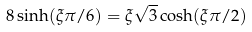<formula> <loc_0><loc_0><loc_500><loc_500>8 \sinh ( \xi \pi / 6 ) = \xi \sqrt { 3 } \cosh ( \xi \pi / 2 ) \,</formula> 